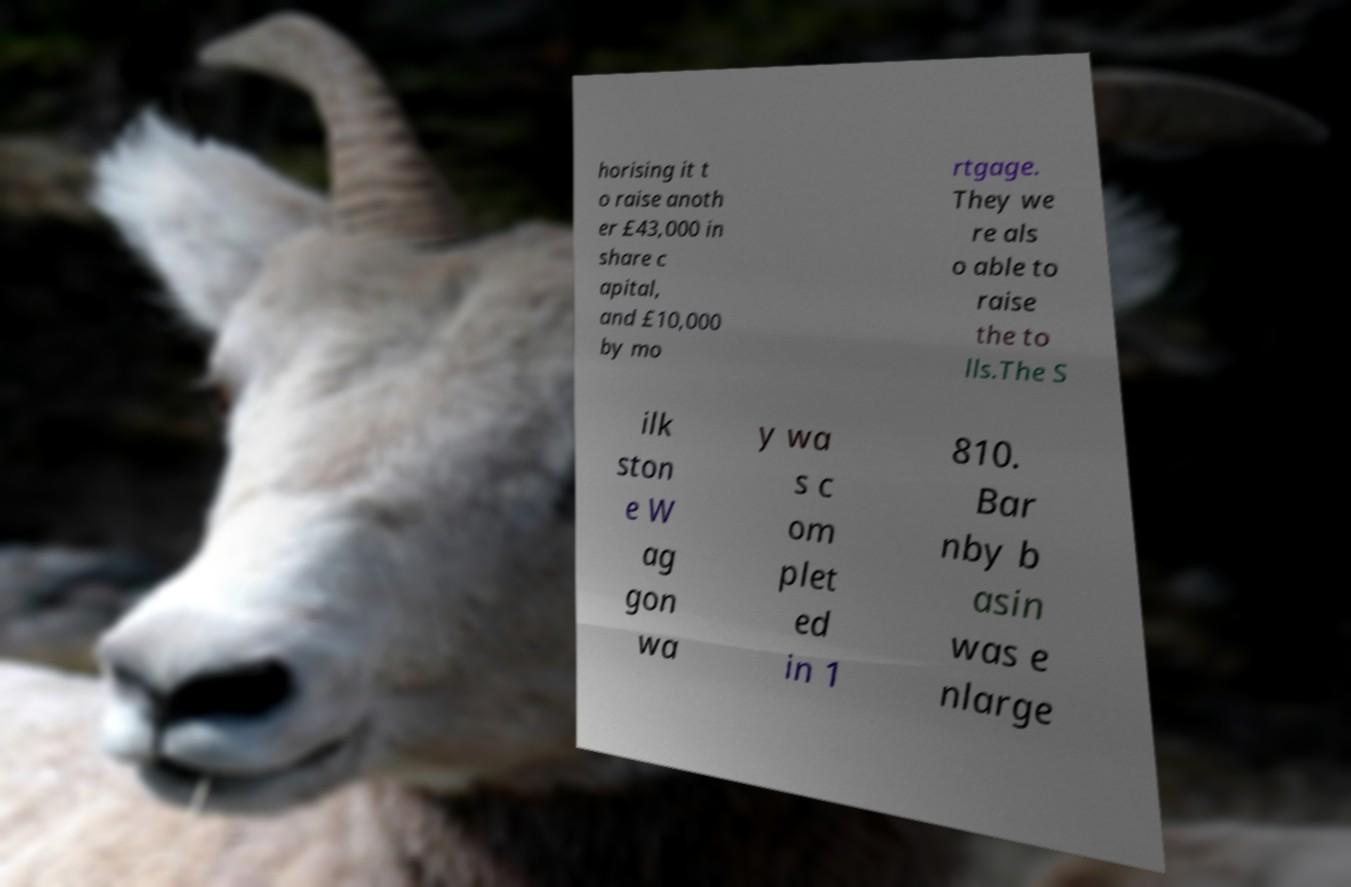There's text embedded in this image that I need extracted. Can you transcribe it verbatim? horising it t o raise anoth er £43,000 in share c apital, and £10,000 by mo rtgage. They we re als o able to raise the to lls.The S ilk ston e W ag gon wa y wa s c om plet ed in 1 810. Bar nby b asin was e nlarge 